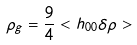<formula> <loc_0><loc_0><loc_500><loc_500>\rho _ { g } = \frac { 9 } { 4 } < h _ { 0 0 } \delta \rho ></formula> 